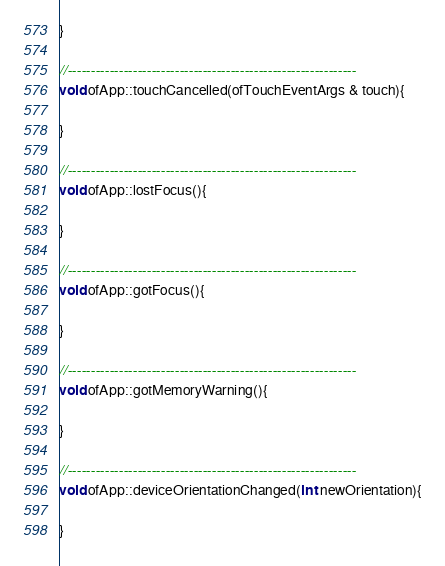Convert code to text. <code><loc_0><loc_0><loc_500><loc_500><_ObjectiveC_>}

//--------------------------------------------------------------
void ofApp::touchCancelled(ofTouchEventArgs & touch){
    
}

//--------------------------------------------------------------
void ofApp::lostFocus(){

}

//--------------------------------------------------------------
void ofApp::gotFocus(){

}

//--------------------------------------------------------------
void ofApp::gotMemoryWarning(){

}

//--------------------------------------------------------------
void ofApp::deviceOrientationChanged(int newOrientation){

}

</code> 